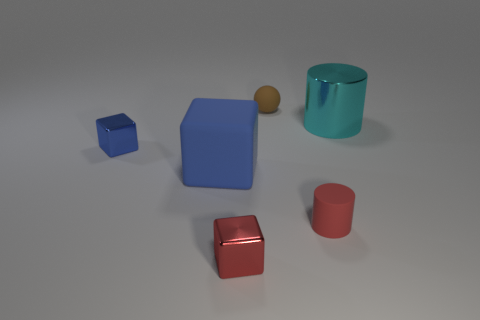Subtract all big cubes. How many cubes are left? 2 Add 1 gray shiny spheres. How many objects exist? 7 Subtract 1 blocks. How many blocks are left? 2 Subtract all red cubes. How many cubes are left? 2 Subtract all balls. How many objects are left? 5 Subtract all brown blocks. Subtract all blue balls. How many blocks are left? 3 Subtract all blue cylinders. How many gray balls are left? 0 Subtract all matte spheres. Subtract all red cylinders. How many objects are left? 4 Add 2 rubber balls. How many rubber balls are left? 3 Add 4 tiny shiny objects. How many tiny shiny objects exist? 6 